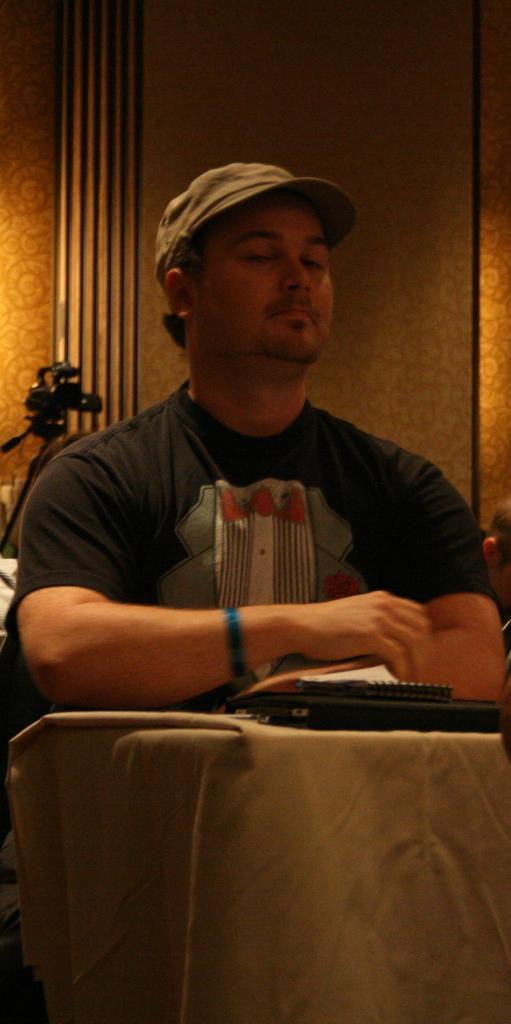Can you describe this image briefly? In this image we can see a person wearing cap. In front of him there are some items. In the back there is a wall. Also we can see a video camera on a stand. 